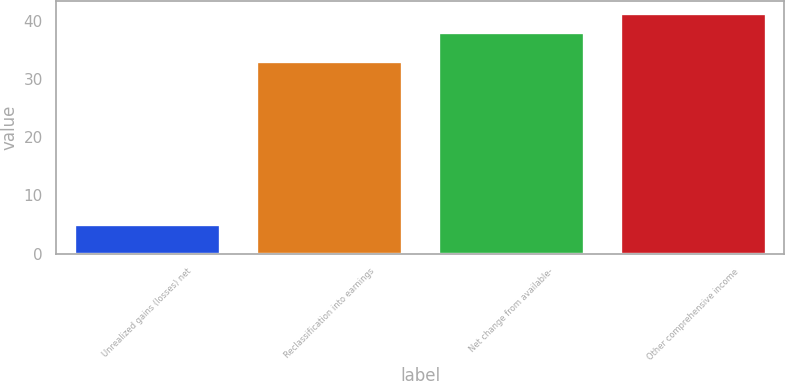Convert chart. <chart><loc_0><loc_0><loc_500><loc_500><bar_chart><fcel>Unrealized gains (losses) net<fcel>Reclassification into earnings<fcel>Net change from available-<fcel>Other comprehensive income<nl><fcel>5<fcel>33<fcel>38<fcel>41.3<nl></chart> 